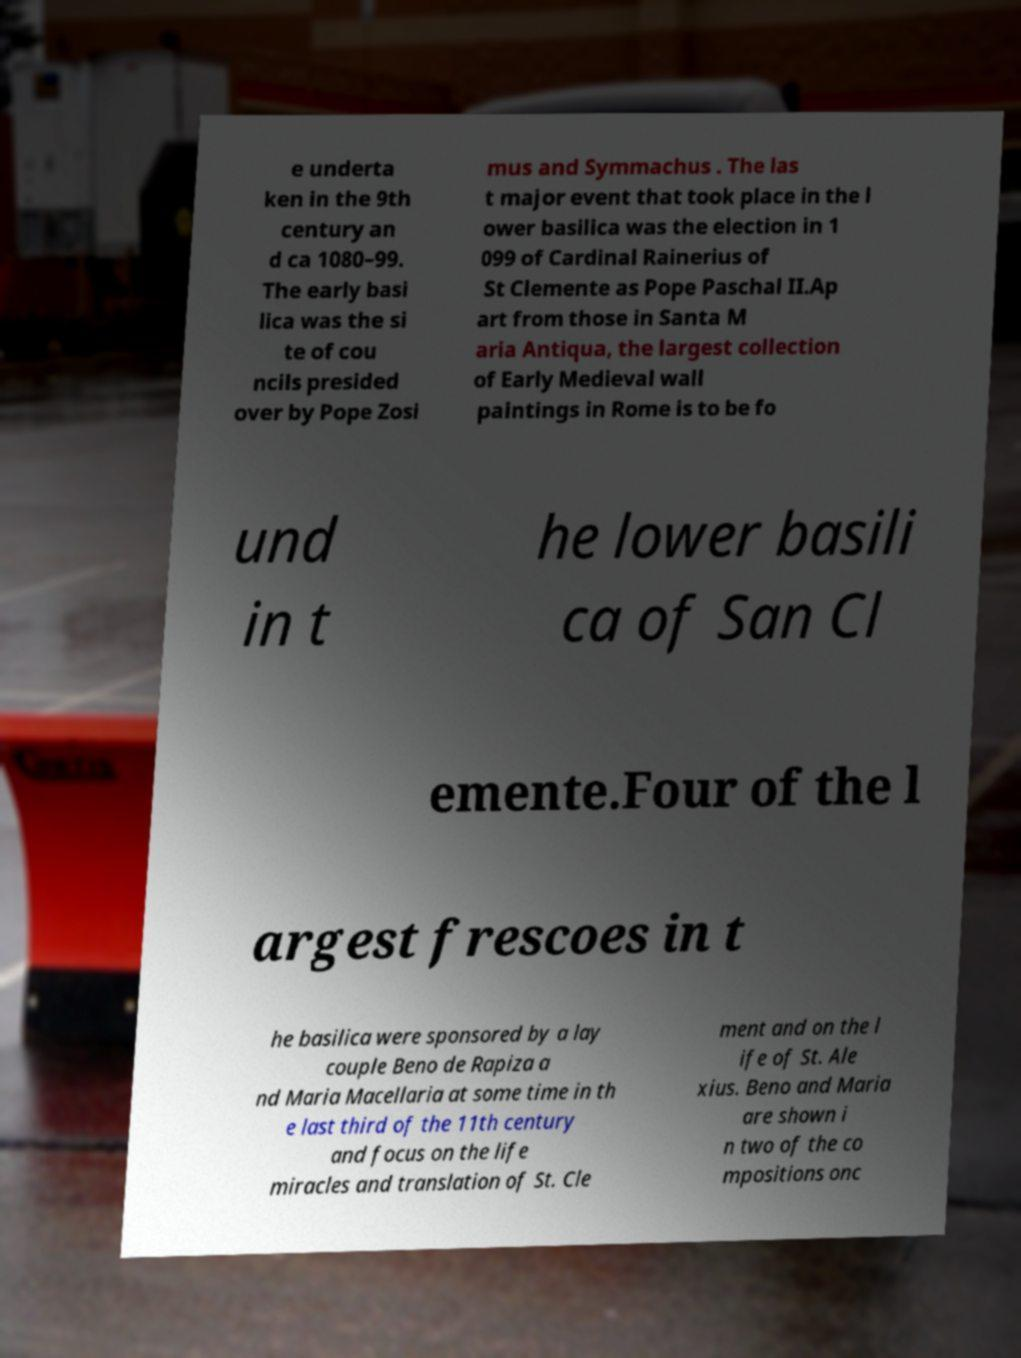Could you assist in decoding the text presented in this image and type it out clearly? e underta ken in the 9th century an d ca 1080–99. The early basi lica was the si te of cou ncils presided over by Pope Zosi mus and Symmachus . The las t major event that took place in the l ower basilica was the election in 1 099 of Cardinal Rainerius of St Clemente as Pope Paschal II.Ap art from those in Santa M aria Antiqua, the largest collection of Early Medieval wall paintings in Rome is to be fo und in t he lower basili ca of San Cl emente.Four of the l argest frescoes in t he basilica were sponsored by a lay couple Beno de Rapiza a nd Maria Macellaria at some time in th e last third of the 11th century and focus on the life miracles and translation of St. Cle ment and on the l ife of St. Ale xius. Beno and Maria are shown i n two of the co mpositions onc 